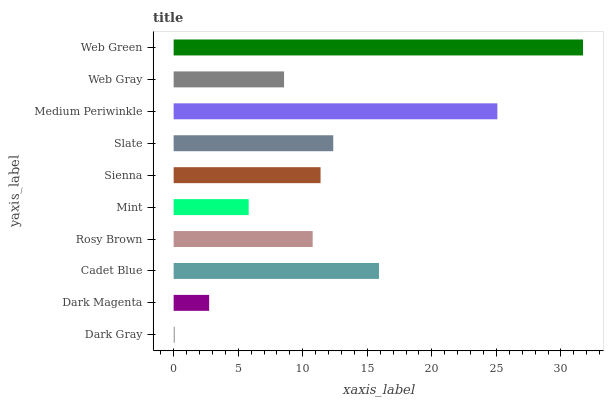Is Dark Gray the minimum?
Answer yes or no. Yes. Is Web Green the maximum?
Answer yes or no. Yes. Is Dark Magenta the minimum?
Answer yes or no. No. Is Dark Magenta the maximum?
Answer yes or no. No. Is Dark Magenta greater than Dark Gray?
Answer yes or no. Yes. Is Dark Gray less than Dark Magenta?
Answer yes or no. Yes. Is Dark Gray greater than Dark Magenta?
Answer yes or no. No. Is Dark Magenta less than Dark Gray?
Answer yes or no. No. Is Sienna the high median?
Answer yes or no. Yes. Is Rosy Brown the low median?
Answer yes or no. Yes. Is Dark Gray the high median?
Answer yes or no. No. Is Web Gray the low median?
Answer yes or no. No. 